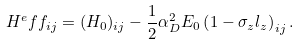Convert formula to latex. <formula><loc_0><loc_0><loc_500><loc_500>H ^ { e } f f _ { i j } = ( H _ { 0 } ) _ { i j } - \frac { 1 } { 2 } \alpha _ { D } ^ { 2 } E _ { 0 } \left ( 1 - \sigma _ { z } l _ { z } \right ) _ { i j } .</formula> 